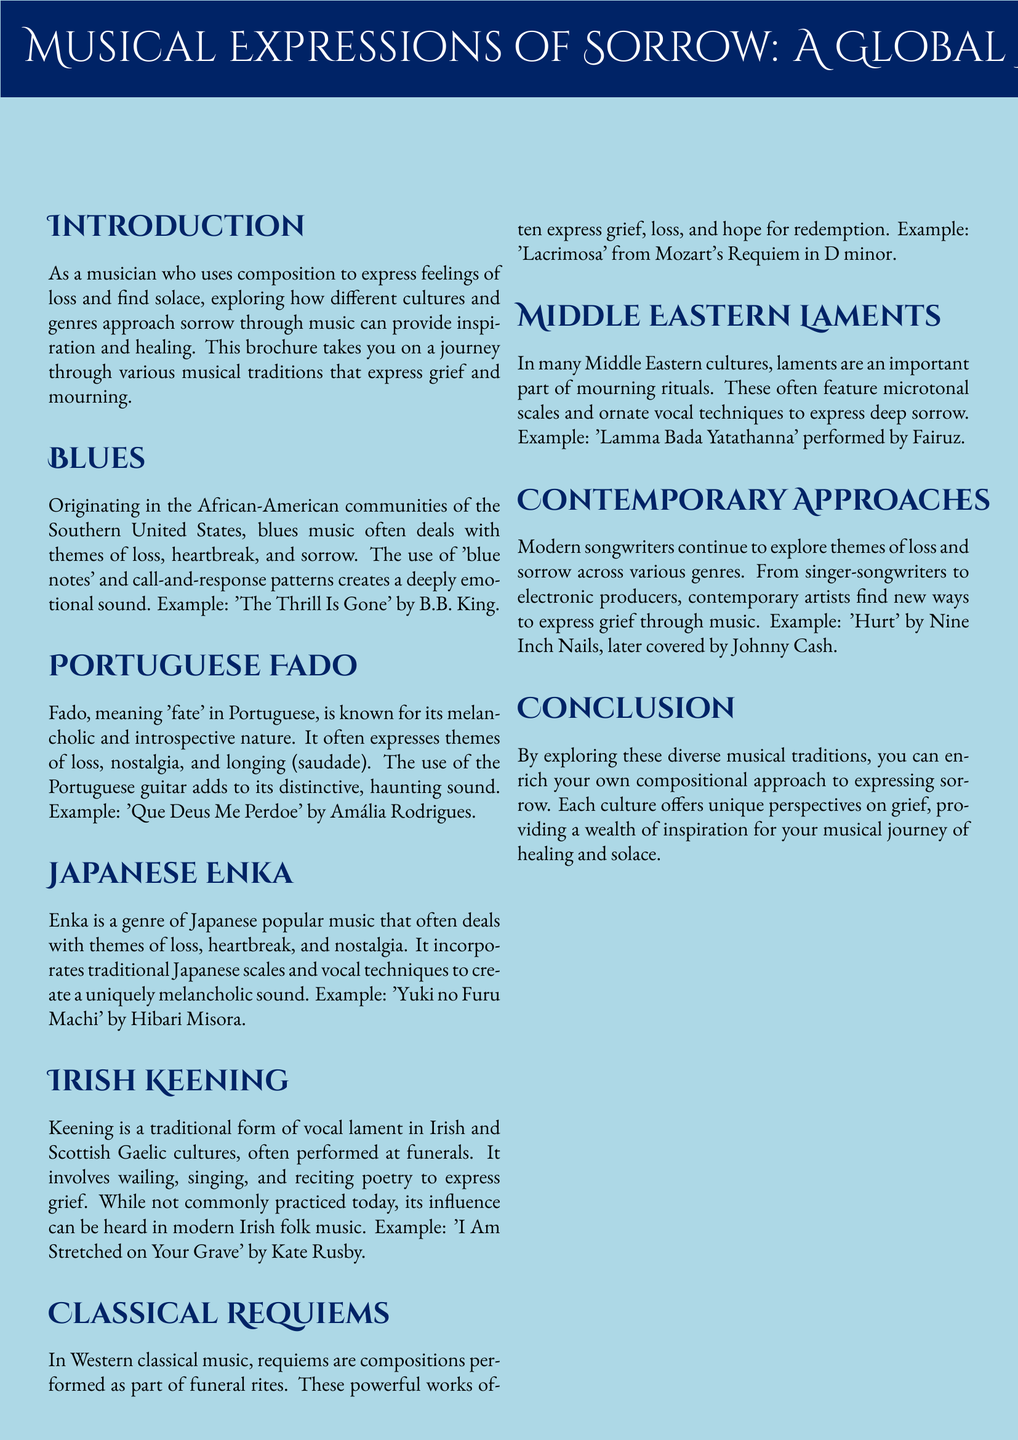What genre originated in the African-American communities of the Southern United States? The document states that blues is the genre originating in these communities and deals with themes of loss and sorrow.
Answer: blues What is the Portuguese term that means 'fate'? The brochure explains that Fado translates to 'fate' in Portuguese, emphasizing its melancholic nature.
Answer: Fado Which example song is associated with Japanese Enka? The document provides 'Yuki no Furu Machi' by Hibari Misora as the example for Japanese Enka.
Answer: Yuki no Furu Machi What is the main theme expressed in Irish Keening? The document discusses that Keening is a traditional form of vocal lament expressing grief.
Answer: grief What type of compositions are performed as part of funeral rites in Western classical music? The text mentions that requiems are the compositions associated with funeral rites and expressions of loss.
Answer: requiems Which artist performed 'Hurt'? According to the brochure, 'Hurt' was originally performed by Nine Inch Nails before being covered by Johnny Cash.
Answer: Nine Inch Nails How does the document categorize modern songwriting regarding sorrow? The document states that modern songwriters continue to explore themes of loss across various genres.
Answer: contemporary approaches What does the title of the brochure emphasize? The title emphasizes a journey through different musical expressions of sorrow found in global traditions.
Answer: Musical Expressions of Sorrow: A Global Journey What musical instrument is associated with Fado? The document states that the Portuguese guitar is a distinctive instrument in Fado music.
Answer: Portuguese guitar 